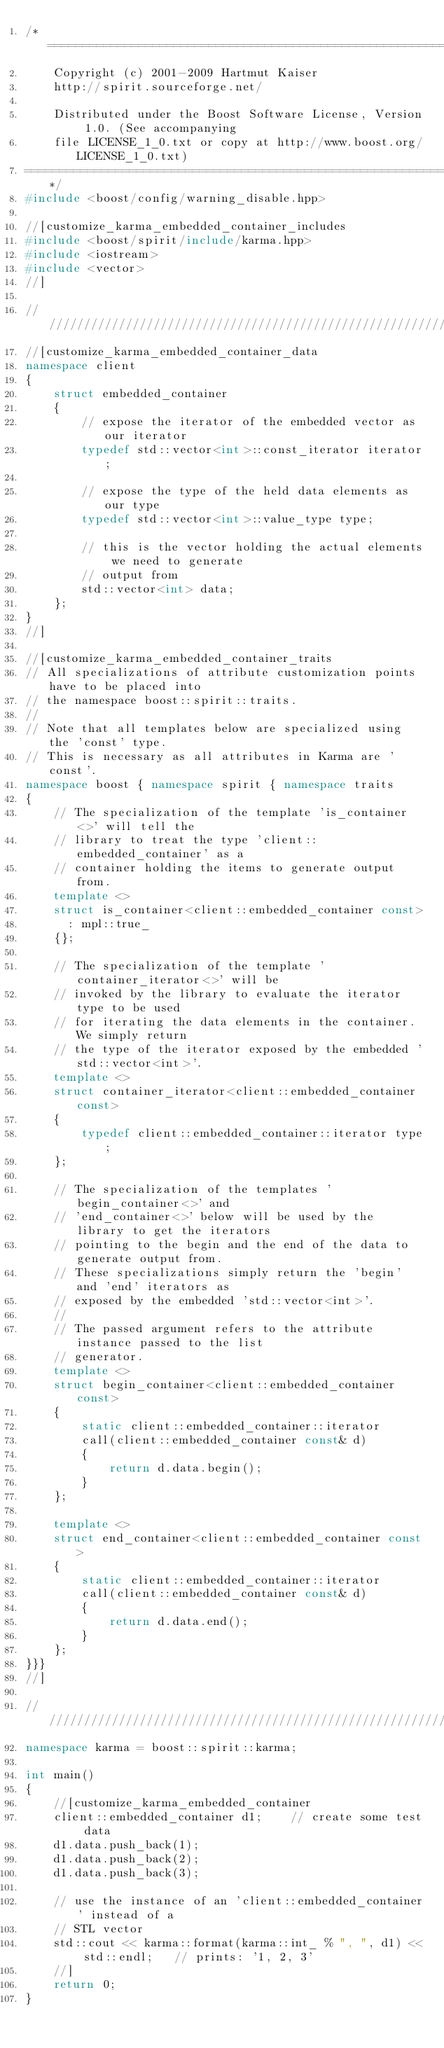Convert code to text. <code><loc_0><loc_0><loc_500><loc_500><_C++_>/*=============================================================================
    Copyright (c) 2001-2009 Hartmut Kaiser
    http://spirit.sourceforge.net/

    Distributed under the Boost Software License, Version 1.0. (See accompanying
    file LICENSE_1_0.txt or copy at http://www.boost.org/LICENSE_1_0.txt)
=============================================================================*/
#include <boost/config/warning_disable.hpp>

//[customize_karma_embedded_container_includes
#include <boost/spirit/include/karma.hpp>
#include <iostream>
#include <vector>
//]

///////////////////////////////////////////////////////////////////////////////
//[customize_karma_embedded_container_data
namespace client
{
    struct embedded_container
    {
        // expose the iterator of the embedded vector as our iterator
        typedef std::vector<int>::const_iterator iterator;

        // expose the type of the held data elements as our type
        typedef std::vector<int>::value_type type;

        // this is the vector holding the actual elements we need to generate 
        // output from
        std::vector<int> data;
    };
}
//]

//[customize_karma_embedded_container_traits
// All specializations of attribute customization points have to be placed into
// the namespace boost::spirit::traits.
//
// Note that all templates below are specialized using the 'const' type.
// This is necessary as all attributes in Karma are 'const'.
namespace boost { namespace spirit { namespace traits
{
    // The specialization of the template 'is_container<>' will tell the 
    // library to treat the type 'client::embedded_container' as a 
    // container holding the items to generate output from.
    template <>
    struct is_container<client::embedded_container const>
      : mpl::true_
    {};

    // The specialization of the template 'container_iterator<>' will be
    // invoked by the library to evaluate the iterator type to be used
    // for iterating the data elements in the container. We simply return
    // the type of the iterator exposed by the embedded 'std::vector<int>'.
    template <>
    struct container_iterator<client::embedded_container const>
    {
        typedef client::embedded_container::iterator type;
    };

    // The specialization of the templates 'begin_container<>' and 
    // 'end_container<>' below will be used by the library to get the iterators 
    // pointing to the begin and the end of the data to generate output from. 
    // These specializations simply return the 'begin' and 'end' iterators as 
    // exposed by the embedded 'std::vector<int>'.
    //
    // The passed argument refers to the attribute instance passed to the list 
    // generator.
    template <>
    struct begin_container<client::embedded_container const>
    {
        static client::embedded_container::iterator 
        call(client::embedded_container const& d)
        {
            return d.data.begin();
        }
    };

    template <>
    struct end_container<client::embedded_container const>
    {
        static client::embedded_container::iterator 
        call(client::embedded_container const& d)
        {
            return d.data.end();
        }
    };
}}}
//]

///////////////////////////////////////////////////////////////////////////////
namespace karma = boost::spirit::karma;

int main()
{
    //[customize_karma_embedded_container
    client::embedded_container d1;    // create some test data
    d1.data.push_back(1);
    d1.data.push_back(2);
    d1.data.push_back(3);

    // use the instance of an 'client::embedded_container' instead of a 
    // STL vector
    std::cout << karma::format(karma::int_ % ", ", d1) << std::endl;   // prints: '1, 2, 3'
    //]
    return 0;
}

</code> 